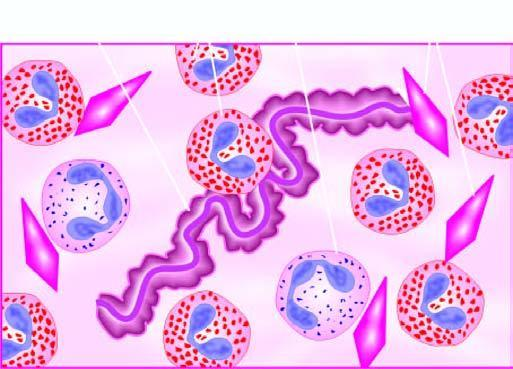does same cellblock, plug in patients with bronchial asthma?
Answer the question using a single word or phrase. No 